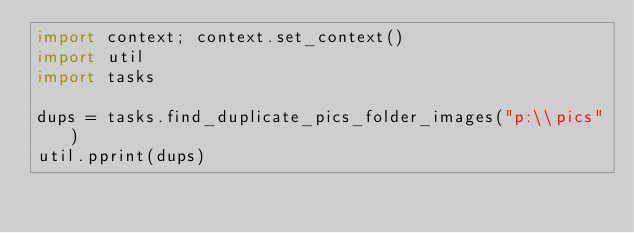<code> <loc_0><loc_0><loc_500><loc_500><_Python_>import context; context.set_context()
import util
import tasks

dups = tasks.find_duplicate_pics_folder_images("p:\\pics")
util.pprint(dups)</code> 